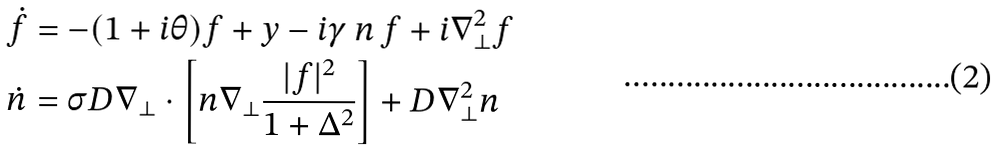<formula> <loc_0><loc_0><loc_500><loc_500>\dot { f } & = - ( 1 + i \theta ) f + y - i \gamma \, n \, f + i \nabla ^ { 2 } _ { \perp } f \\ \dot { n } & = \sigma D \nabla _ { \perp } \cdot \left [ n \nabla _ { \perp } \frac { | f | ^ { 2 } } { 1 + \Delta ^ { 2 } } \right ] + D \nabla _ { \perp } ^ { 2 } n</formula> 